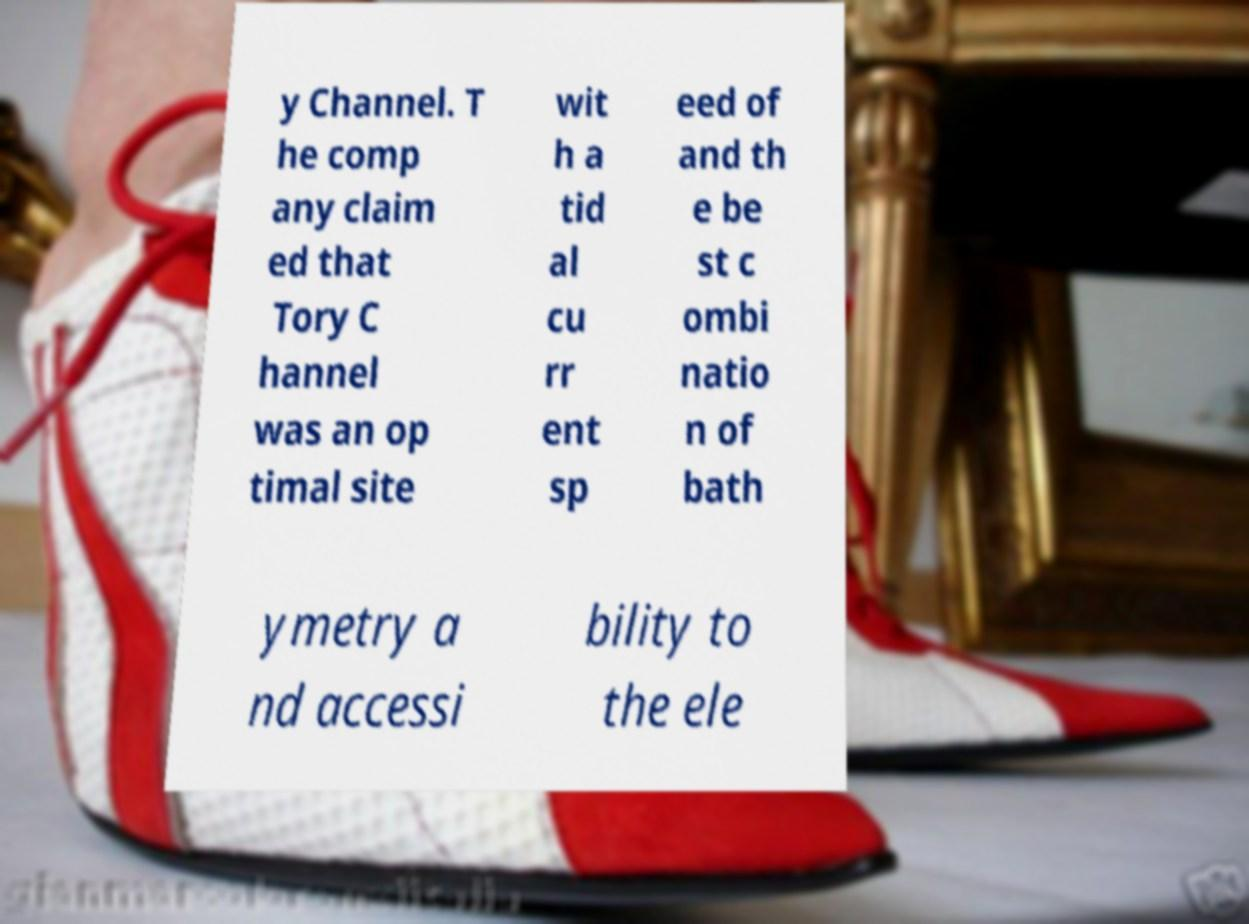What messages or text are displayed in this image? I need them in a readable, typed format. y Channel. T he comp any claim ed that Tory C hannel was an op timal site wit h a tid al cu rr ent sp eed of and th e be st c ombi natio n of bath ymetry a nd accessi bility to the ele 